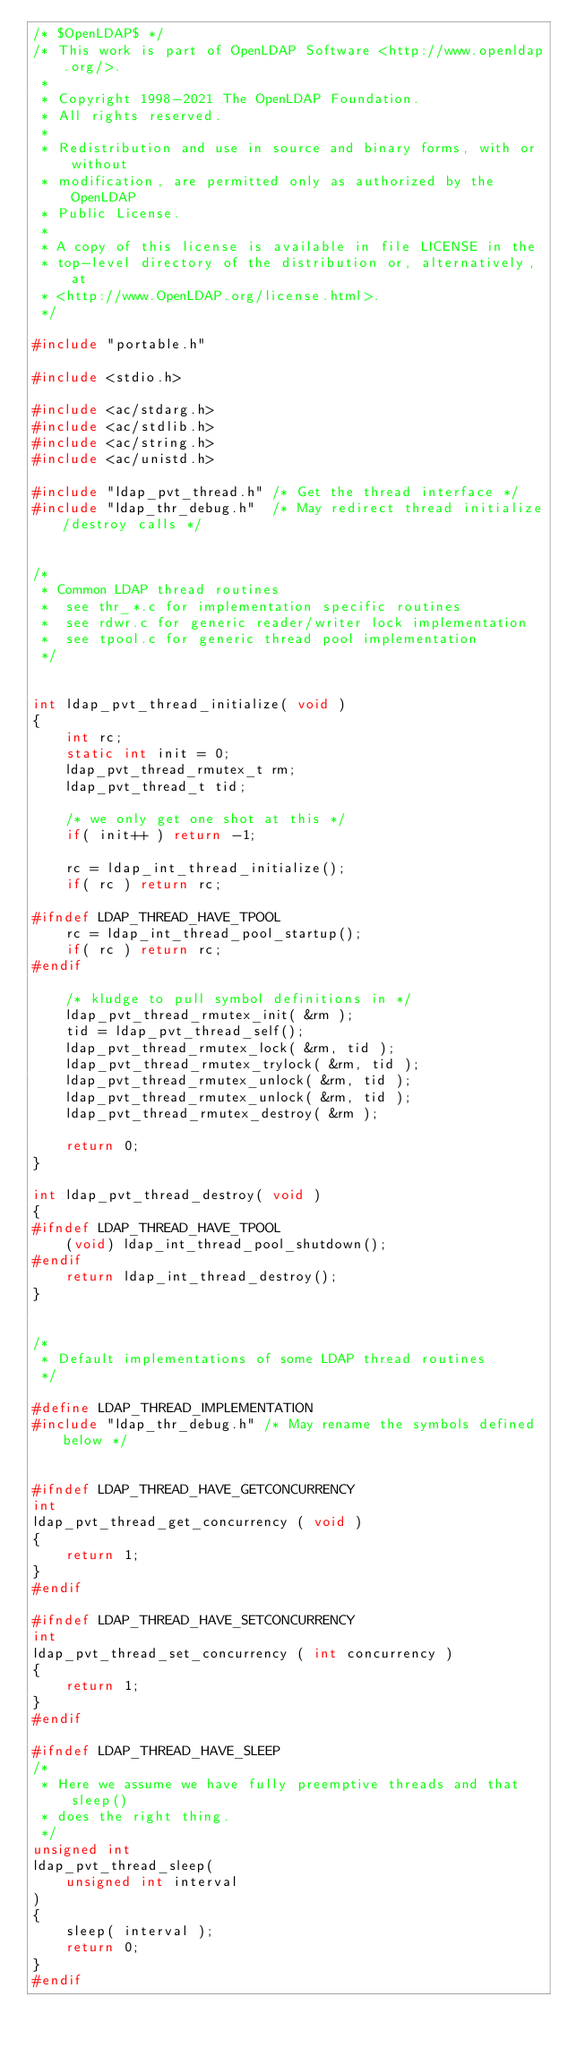<code> <loc_0><loc_0><loc_500><loc_500><_C_>/* $OpenLDAP$ */
/* This work is part of OpenLDAP Software <http://www.openldap.org/>.
 *
 * Copyright 1998-2021 The OpenLDAP Foundation.
 * All rights reserved.
 *
 * Redistribution and use in source and binary forms, with or without
 * modification, are permitted only as authorized by the OpenLDAP
 * Public License.
 *
 * A copy of this license is available in file LICENSE in the
 * top-level directory of the distribution or, alternatively, at
 * <http://www.OpenLDAP.org/license.html>.
 */

#include "portable.h"

#include <stdio.h>

#include <ac/stdarg.h>
#include <ac/stdlib.h>
#include <ac/string.h>
#include <ac/unistd.h>

#include "ldap_pvt_thread.h" /* Get the thread interface */
#include "ldap_thr_debug.h"  /* May redirect thread initialize/destroy calls */


/*
 * Common LDAP thread routines
 *	see thr_*.c for implementation specific routines
 *	see rdwr.c for generic reader/writer lock implementation
 *	see tpool.c for generic thread pool implementation
 */


int ldap_pvt_thread_initialize( void )
{
	int rc;
	static int init = 0;
	ldap_pvt_thread_rmutex_t rm;
	ldap_pvt_thread_t tid;

	/* we only get one shot at this */
	if( init++ ) return -1;

	rc = ldap_int_thread_initialize();
	if( rc ) return rc;

#ifndef LDAP_THREAD_HAVE_TPOOL
	rc = ldap_int_thread_pool_startup();
	if( rc ) return rc;
#endif

	/* kludge to pull symbol definitions in */
	ldap_pvt_thread_rmutex_init( &rm );
	tid = ldap_pvt_thread_self();
	ldap_pvt_thread_rmutex_lock( &rm, tid );
	ldap_pvt_thread_rmutex_trylock( &rm, tid );
	ldap_pvt_thread_rmutex_unlock( &rm, tid );
	ldap_pvt_thread_rmutex_unlock( &rm, tid );
	ldap_pvt_thread_rmutex_destroy( &rm );

	return 0;
}

int ldap_pvt_thread_destroy( void )
{
#ifndef LDAP_THREAD_HAVE_TPOOL
	(void) ldap_int_thread_pool_shutdown();
#endif
	return ldap_int_thread_destroy();
}


/*
 * Default implementations of some LDAP thread routines
 */

#define LDAP_THREAD_IMPLEMENTATION
#include "ldap_thr_debug.h"	/* May rename the symbols defined below */


#ifndef LDAP_THREAD_HAVE_GETCONCURRENCY
int
ldap_pvt_thread_get_concurrency ( void )
{
	return 1;
}
#endif

#ifndef LDAP_THREAD_HAVE_SETCONCURRENCY
int
ldap_pvt_thread_set_concurrency ( int concurrency )
{
	return 1;
}
#endif

#ifndef LDAP_THREAD_HAVE_SLEEP
/*
 * Here we assume we have fully preemptive threads and that sleep()
 * does the right thing.
 */
unsigned int
ldap_pvt_thread_sleep(
	unsigned int interval
)
{
	sleep( interval );
	return 0;
}
#endif
</code> 